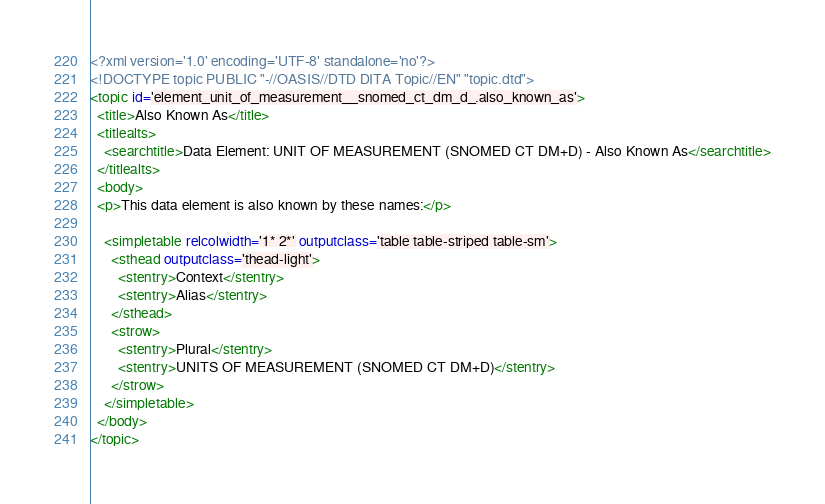<code> <loc_0><loc_0><loc_500><loc_500><_XML_><?xml version='1.0' encoding='UTF-8' standalone='no'?>
<!DOCTYPE topic PUBLIC "-//OASIS//DTD DITA Topic//EN" "topic.dtd">
<topic id='element_unit_of_measurement__snomed_ct_dm_d_.also_known_as'>
  <title>Also Known As</title>
  <titlealts>
    <searchtitle>Data Element: UNIT OF MEASUREMENT (SNOMED CT DM+D) - Also Known As</searchtitle>
  </titlealts>
  <body>
  <p>This data element is also known by these names:</p>

    <simpletable relcolwidth='1* 2*' outputclass='table table-striped table-sm'>
      <sthead outputclass='thead-light'>
        <stentry>Context</stentry>
        <stentry>Alias</stentry>
      </sthead>
      <strow>
        <stentry>Plural</stentry>
        <stentry>UNITS OF MEASUREMENT (SNOMED CT DM+D)</stentry>
      </strow>
    </simpletable>
  </body>
</topic></code> 